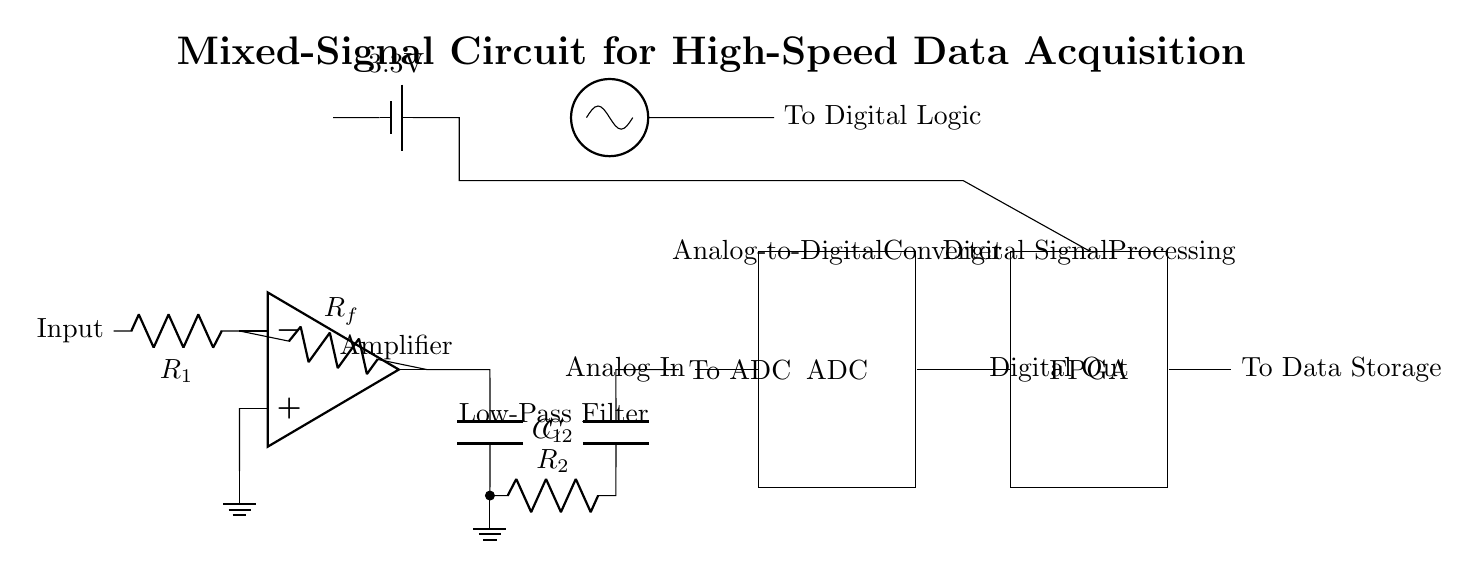What type of amplifier is used in this circuit? The circuit uses an operational amplifier, indicated by the op amp symbol in the diagram. The op amp is positioned at the beginning of the circuit to amplify the input signal.
Answer: operational amplifier What is the voltage supply for this circuit? The battery source connected at the top of the circuit is labeled with a voltage of 3.3V, which reflects the power supply voltage for the entire circuit.
Answer: 3.3V What components are involved in the anti-aliasing filter? The anti-aliasing filter consists of two capacitors (C1 and C2) and one resistor (R2) connected in sequence which helps smooth the signal before it is fed into the ADC.
Answer: two capacitors and one resistor How does the clock generator connect to the rest of the circuit? The clock generator, shown as an oscillator, connects to the digital logic section of the circuit, indicating that it provides the necessary timing for the digital processing operations.
Answer: to Digital Logic What is the purpose of the analog-to-digital converter in this circuit? The ADC converts the analog signals processed by the amplifier and anti-aliasing filter into digital signals that can be handled by the FPGA for further processing.
Answer: conversion of analog signals to digital Which component is responsible for data storage? The component responsible for data storage is the FPGA, which receives the digital output from the ADC and processes it for storage purposes.
Answer: FPGA Explain the relationship between the amplifier and the ADC in this circuit. The operational amplifier amplifies the incoming analog signal and passes it through the anti-aliasing filter before sending it to the ADC, which digitizes the adjusted analog signal for further digital processing in the FPGA.
Answer: Amplifies and digitizes signal 